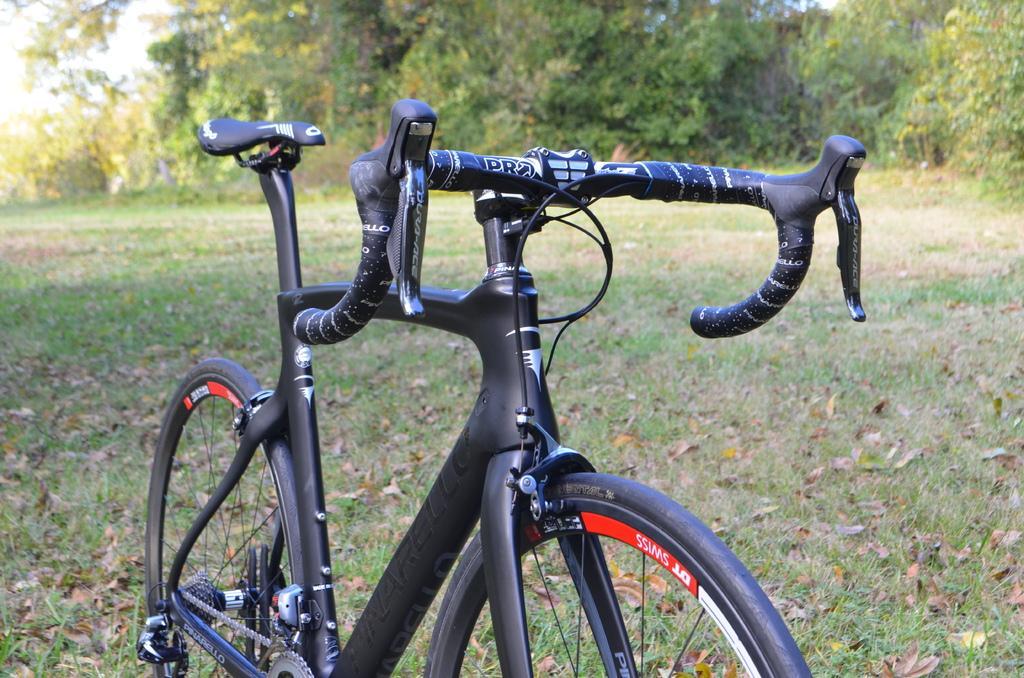How would you summarize this image in a sentence or two? In this picture I can see a cycle in front which is of black in color and I see something is written on it and I see the grass. In the background I see number of trees. 